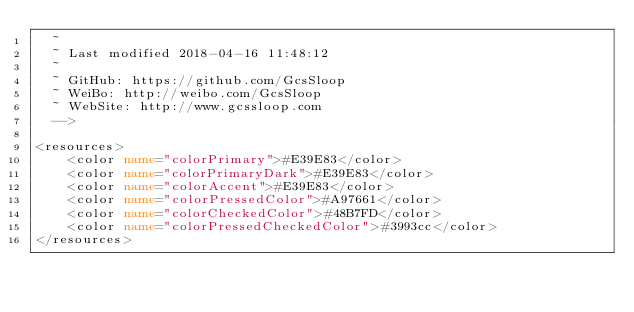<code> <loc_0><loc_0><loc_500><loc_500><_XML_>  ~
  ~ Last modified 2018-04-16 11:48:12
  ~
  ~ GitHub: https://github.com/GcsSloop
  ~ WeiBo: http://weibo.com/GcsSloop
  ~ WebSite: http://www.gcssloop.com
  -->

<resources>
    <color name="colorPrimary">#E39E83</color>
    <color name="colorPrimaryDark">#E39E83</color>
    <color name="colorAccent">#E39E83</color>
    <color name="colorPressedColor">#A97661</color>
    <color name="colorCheckedColor">#48B7FD</color>
    <color name="colorPressedCheckedColor">#3993cc</color>
</resources>
</code> 